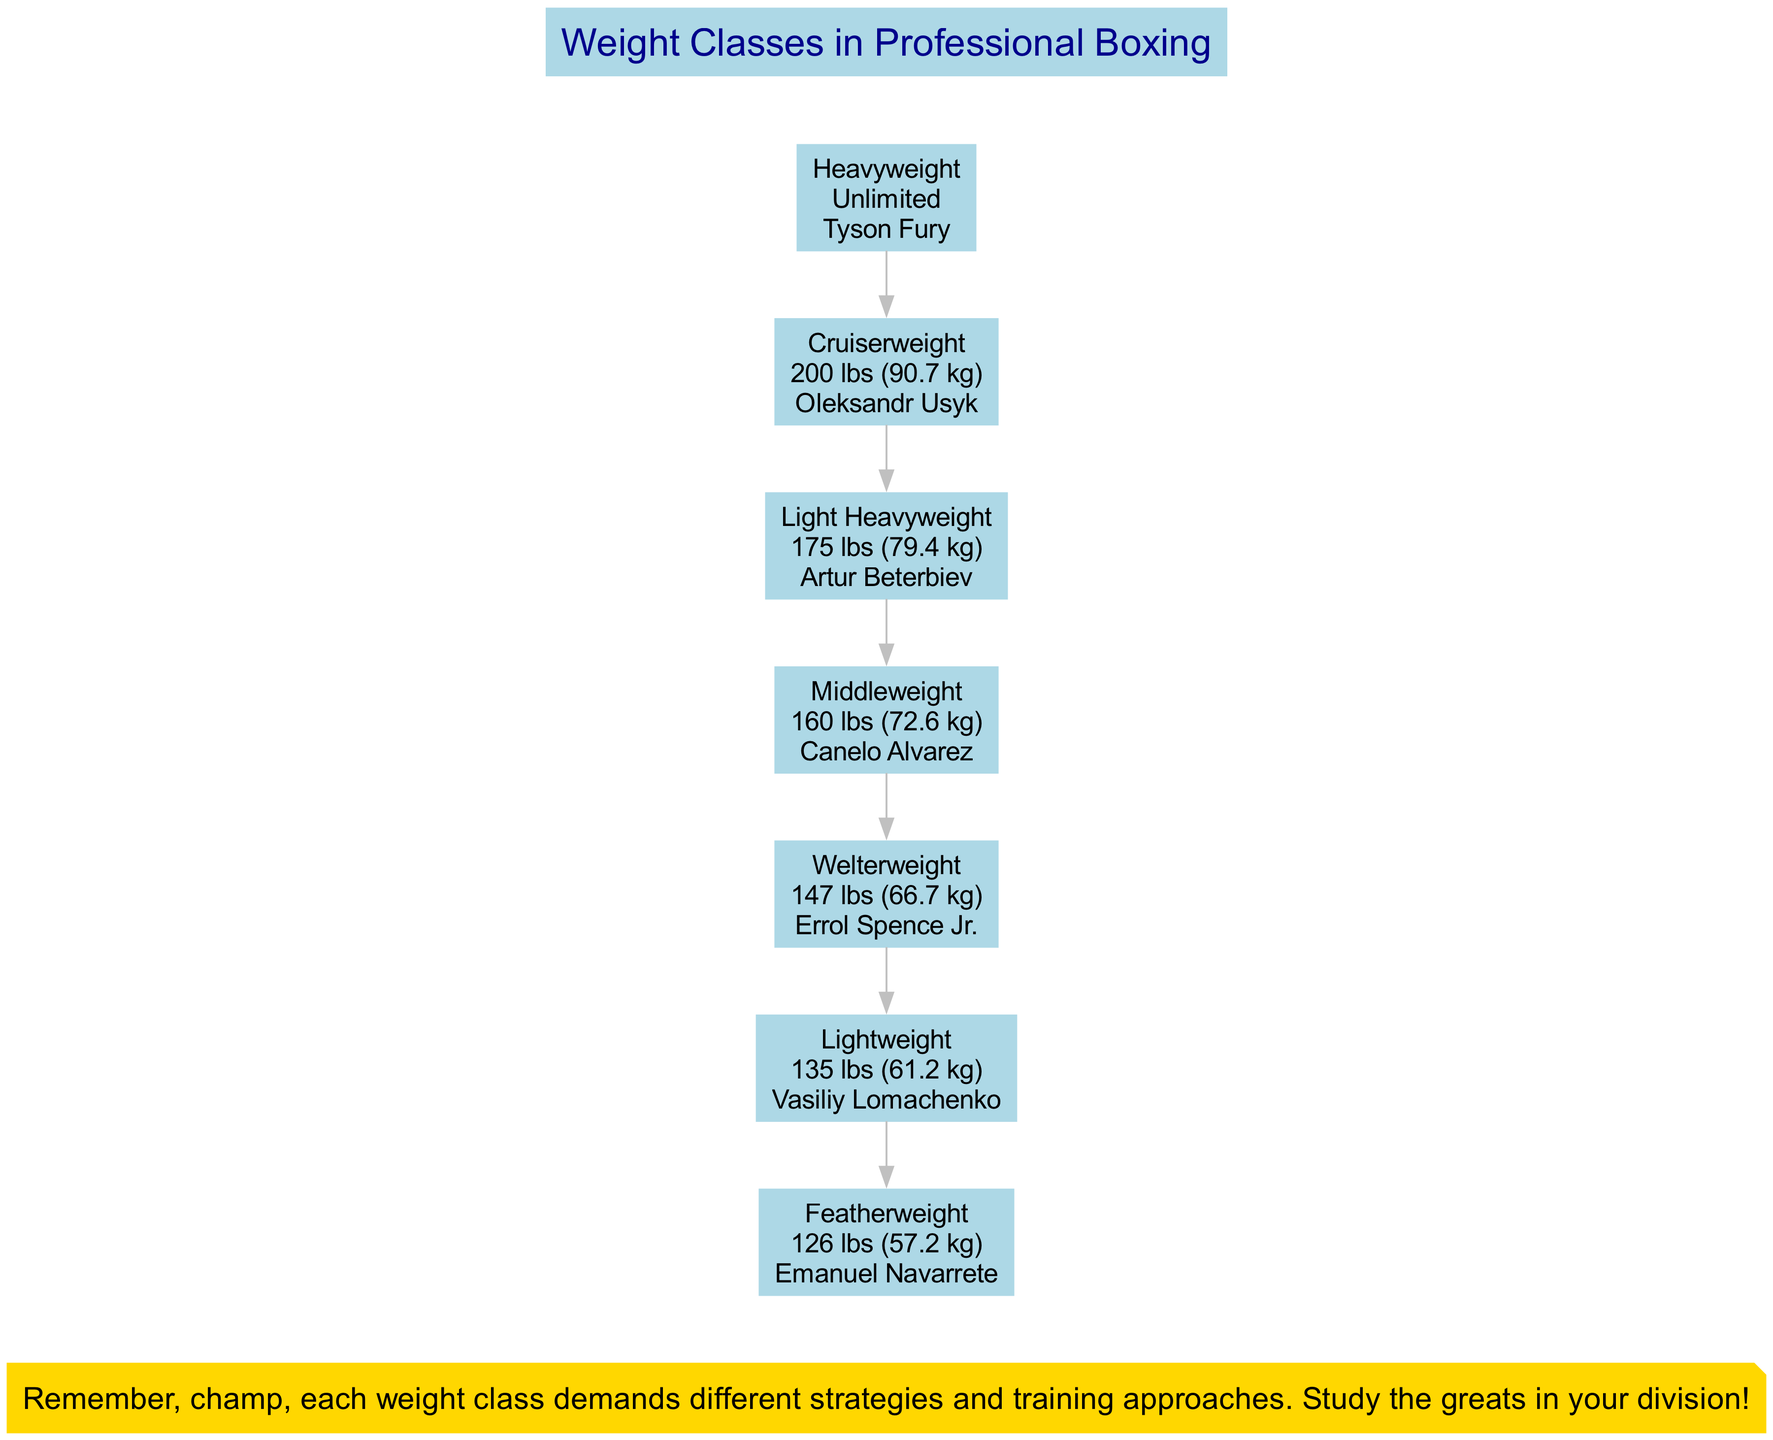What is the limit for the Cruiserweight class? The Cruiserweight class has a limit of 200 lbs. This is directly stated in the diagram next to the name of the weight class.
Answer: 200 lbs Who is the example fighter for Featherweight? The example fighter for the Featherweight class is Emanuel Navarrete. This information is found within the box representing the Featherweight weight class.
Answer: Emanuel Navarrete Which weight class has no upper limit? The Heavyweight class has no upper limit. This is shown in the diagram, indicating "Unlimited" next to the Heavyweight class name.
Answer: Heavyweight How many weight classes are listed in the diagram? There are a total of seven weight classes shown in the diagram, one for each class represented in the list.
Answer: 7 Which fighter is an example in the Middleweight class? The example fighter for the Middleweight class is Canelo Alvarez. This is directly listed next to the Middleweight category in the diagram.
Answer: Canelo Alvarez What is the weight limit for Light Heavyweight? The Light Heavyweight class has a limit of 175 lbs. This limit is specified in the information section regarding the Light Heavyweight weight class.
Answer: 175 lbs Which two weight classes directly precede the Welterweight class in the diagram? The two weight classes that come before Welterweight are Lightweight and Middleweight. This can be determined by following the edge connections upward in the diagram from Welterweight.
Answer: Lightweight, Middleweight What trainer tip is included in the diagram? The trainer tip emphasizes the importance of understanding strategies and training approaches based on weight classes. This is found at the bottom of the diagram.
Answer: Remember, champ, each weight class demands different strategies and training approaches. Study the greats in your division! 